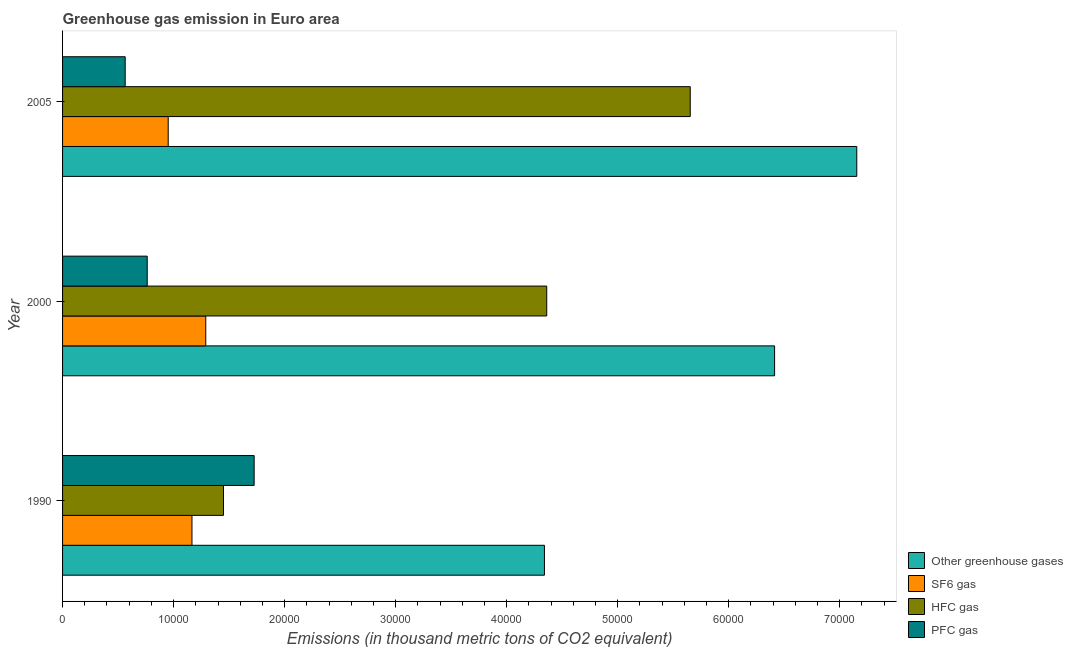Are the number of bars per tick equal to the number of legend labels?
Give a very brief answer. Yes. How many bars are there on the 3rd tick from the top?
Offer a terse response. 4. How many bars are there on the 2nd tick from the bottom?
Ensure brevity in your answer.  4. What is the label of the 3rd group of bars from the top?
Ensure brevity in your answer.  1990. What is the emission of hfc gas in 2000?
Keep it short and to the point. 4.36e+04. Across all years, what is the maximum emission of hfc gas?
Make the answer very short. 5.65e+04. Across all years, what is the minimum emission of pfc gas?
Make the answer very short. 5640.06. In which year was the emission of sf6 gas minimum?
Ensure brevity in your answer.  2005. What is the total emission of sf6 gas in the graph?
Your answer should be compact. 3.41e+04. What is the difference between the emission of greenhouse gases in 2000 and that in 2005?
Keep it short and to the point. -7401.3. What is the difference between the emission of pfc gas in 2000 and the emission of hfc gas in 1990?
Ensure brevity in your answer.  -6866.6. What is the average emission of hfc gas per year?
Give a very brief answer. 3.82e+04. In the year 2000, what is the difference between the emission of pfc gas and emission of sf6 gas?
Offer a terse response. -5272.2. In how many years, is the emission of hfc gas greater than 42000 thousand metric tons?
Offer a terse response. 2. What is the ratio of the emission of sf6 gas in 2000 to that in 2005?
Ensure brevity in your answer.  1.36. Is the difference between the emission of pfc gas in 1990 and 2000 greater than the difference between the emission of sf6 gas in 1990 and 2000?
Offer a terse response. Yes. What is the difference between the highest and the second highest emission of hfc gas?
Keep it short and to the point. 1.29e+04. What is the difference between the highest and the lowest emission of greenhouse gases?
Offer a terse response. 2.81e+04. Is it the case that in every year, the sum of the emission of greenhouse gases and emission of sf6 gas is greater than the sum of emission of hfc gas and emission of pfc gas?
Your answer should be very brief. Yes. What does the 4th bar from the top in 2000 represents?
Your response must be concise. Other greenhouse gases. What does the 1st bar from the bottom in 1990 represents?
Keep it short and to the point. Other greenhouse gases. How many years are there in the graph?
Ensure brevity in your answer.  3. Are the values on the major ticks of X-axis written in scientific E-notation?
Your answer should be very brief. No. Does the graph contain any zero values?
Provide a short and direct response. No. Does the graph contain grids?
Your answer should be very brief. No. Where does the legend appear in the graph?
Provide a succinct answer. Bottom right. How many legend labels are there?
Provide a short and direct response. 4. How are the legend labels stacked?
Give a very brief answer. Vertical. What is the title of the graph?
Keep it short and to the point. Greenhouse gas emission in Euro area. What is the label or title of the X-axis?
Offer a terse response. Emissions (in thousand metric tons of CO2 equivalent). What is the label or title of the Y-axis?
Your response must be concise. Year. What is the Emissions (in thousand metric tons of CO2 equivalent) of Other greenhouse gases in 1990?
Provide a succinct answer. 4.34e+04. What is the Emissions (in thousand metric tons of CO2 equivalent) of SF6 gas in 1990?
Give a very brief answer. 1.17e+04. What is the Emissions (in thousand metric tons of CO2 equivalent) of HFC gas in 1990?
Offer a very short reply. 1.45e+04. What is the Emissions (in thousand metric tons of CO2 equivalent) of PFC gas in 1990?
Your answer should be compact. 1.73e+04. What is the Emissions (in thousand metric tons of CO2 equivalent) in Other greenhouse gases in 2000?
Offer a terse response. 6.41e+04. What is the Emissions (in thousand metric tons of CO2 equivalent) of SF6 gas in 2000?
Your response must be concise. 1.29e+04. What is the Emissions (in thousand metric tons of CO2 equivalent) of HFC gas in 2000?
Make the answer very short. 4.36e+04. What is the Emissions (in thousand metric tons of CO2 equivalent) in PFC gas in 2000?
Provide a succinct answer. 7625. What is the Emissions (in thousand metric tons of CO2 equivalent) of Other greenhouse gases in 2005?
Provide a succinct answer. 7.15e+04. What is the Emissions (in thousand metric tons of CO2 equivalent) of SF6 gas in 2005?
Your response must be concise. 9513.72. What is the Emissions (in thousand metric tons of CO2 equivalent) in HFC gas in 2005?
Ensure brevity in your answer.  5.65e+04. What is the Emissions (in thousand metric tons of CO2 equivalent) in PFC gas in 2005?
Provide a short and direct response. 5640.06. Across all years, what is the maximum Emissions (in thousand metric tons of CO2 equivalent) in Other greenhouse gases?
Offer a very short reply. 7.15e+04. Across all years, what is the maximum Emissions (in thousand metric tons of CO2 equivalent) in SF6 gas?
Offer a terse response. 1.29e+04. Across all years, what is the maximum Emissions (in thousand metric tons of CO2 equivalent) of HFC gas?
Offer a terse response. 5.65e+04. Across all years, what is the maximum Emissions (in thousand metric tons of CO2 equivalent) in PFC gas?
Offer a terse response. 1.73e+04. Across all years, what is the minimum Emissions (in thousand metric tons of CO2 equivalent) in Other greenhouse gases?
Give a very brief answer. 4.34e+04. Across all years, what is the minimum Emissions (in thousand metric tons of CO2 equivalent) in SF6 gas?
Provide a short and direct response. 9513.72. Across all years, what is the minimum Emissions (in thousand metric tons of CO2 equivalent) in HFC gas?
Keep it short and to the point. 1.45e+04. Across all years, what is the minimum Emissions (in thousand metric tons of CO2 equivalent) of PFC gas?
Give a very brief answer. 5640.06. What is the total Emissions (in thousand metric tons of CO2 equivalent) of Other greenhouse gases in the graph?
Give a very brief answer. 1.79e+05. What is the total Emissions (in thousand metric tons of CO2 equivalent) of SF6 gas in the graph?
Keep it short and to the point. 3.41e+04. What is the total Emissions (in thousand metric tons of CO2 equivalent) of HFC gas in the graph?
Provide a short and direct response. 1.15e+05. What is the total Emissions (in thousand metric tons of CO2 equivalent) in PFC gas in the graph?
Your answer should be compact. 3.05e+04. What is the difference between the Emissions (in thousand metric tons of CO2 equivalent) in Other greenhouse gases in 1990 and that in 2000?
Your answer should be compact. -2.07e+04. What is the difference between the Emissions (in thousand metric tons of CO2 equivalent) of SF6 gas in 1990 and that in 2000?
Keep it short and to the point. -1242.6. What is the difference between the Emissions (in thousand metric tons of CO2 equivalent) of HFC gas in 1990 and that in 2000?
Keep it short and to the point. -2.91e+04. What is the difference between the Emissions (in thousand metric tons of CO2 equivalent) of PFC gas in 1990 and that in 2000?
Make the answer very short. 9630.1. What is the difference between the Emissions (in thousand metric tons of CO2 equivalent) in Other greenhouse gases in 1990 and that in 2005?
Offer a terse response. -2.81e+04. What is the difference between the Emissions (in thousand metric tons of CO2 equivalent) in SF6 gas in 1990 and that in 2005?
Provide a short and direct response. 2140.88. What is the difference between the Emissions (in thousand metric tons of CO2 equivalent) in HFC gas in 1990 and that in 2005?
Make the answer very short. -4.20e+04. What is the difference between the Emissions (in thousand metric tons of CO2 equivalent) of PFC gas in 1990 and that in 2005?
Make the answer very short. 1.16e+04. What is the difference between the Emissions (in thousand metric tons of CO2 equivalent) in Other greenhouse gases in 2000 and that in 2005?
Provide a short and direct response. -7401.3. What is the difference between the Emissions (in thousand metric tons of CO2 equivalent) in SF6 gas in 2000 and that in 2005?
Give a very brief answer. 3383.48. What is the difference between the Emissions (in thousand metric tons of CO2 equivalent) of HFC gas in 2000 and that in 2005?
Offer a very short reply. -1.29e+04. What is the difference between the Emissions (in thousand metric tons of CO2 equivalent) in PFC gas in 2000 and that in 2005?
Provide a succinct answer. 1984.94. What is the difference between the Emissions (in thousand metric tons of CO2 equivalent) in Other greenhouse gases in 1990 and the Emissions (in thousand metric tons of CO2 equivalent) in SF6 gas in 2000?
Provide a short and direct response. 3.05e+04. What is the difference between the Emissions (in thousand metric tons of CO2 equivalent) of Other greenhouse gases in 1990 and the Emissions (in thousand metric tons of CO2 equivalent) of HFC gas in 2000?
Ensure brevity in your answer.  -206.3. What is the difference between the Emissions (in thousand metric tons of CO2 equivalent) of Other greenhouse gases in 1990 and the Emissions (in thousand metric tons of CO2 equivalent) of PFC gas in 2000?
Ensure brevity in your answer.  3.58e+04. What is the difference between the Emissions (in thousand metric tons of CO2 equivalent) in SF6 gas in 1990 and the Emissions (in thousand metric tons of CO2 equivalent) in HFC gas in 2000?
Ensure brevity in your answer.  -3.20e+04. What is the difference between the Emissions (in thousand metric tons of CO2 equivalent) in SF6 gas in 1990 and the Emissions (in thousand metric tons of CO2 equivalent) in PFC gas in 2000?
Provide a succinct answer. 4029.6. What is the difference between the Emissions (in thousand metric tons of CO2 equivalent) of HFC gas in 1990 and the Emissions (in thousand metric tons of CO2 equivalent) of PFC gas in 2000?
Your answer should be very brief. 6866.6. What is the difference between the Emissions (in thousand metric tons of CO2 equivalent) of Other greenhouse gases in 1990 and the Emissions (in thousand metric tons of CO2 equivalent) of SF6 gas in 2005?
Offer a very short reply. 3.39e+04. What is the difference between the Emissions (in thousand metric tons of CO2 equivalent) of Other greenhouse gases in 1990 and the Emissions (in thousand metric tons of CO2 equivalent) of HFC gas in 2005?
Provide a short and direct response. -1.31e+04. What is the difference between the Emissions (in thousand metric tons of CO2 equivalent) of Other greenhouse gases in 1990 and the Emissions (in thousand metric tons of CO2 equivalent) of PFC gas in 2005?
Your response must be concise. 3.78e+04. What is the difference between the Emissions (in thousand metric tons of CO2 equivalent) in SF6 gas in 1990 and the Emissions (in thousand metric tons of CO2 equivalent) in HFC gas in 2005?
Keep it short and to the point. -4.49e+04. What is the difference between the Emissions (in thousand metric tons of CO2 equivalent) of SF6 gas in 1990 and the Emissions (in thousand metric tons of CO2 equivalent) of PFC gas in 2005?
Offer a very short reply. 6014.54. What is the difference between the Emissions (in thousand metric tons of CO2 equivalent) in HFC gas in 1990 and the Emissions (in thousand metric tons of CO2 equivalent) in PFC gas in 2005?
Offer a very short reply. 8851.54. What is the difference between the Emissions (in thousand metric tons of CO2 equivalent) of Other greenhouse gases in 2000 and the Emissions (in thousand metric tons of CO2 equivalent) of SF6 gas in 2005?
Give a very brief answer. 5.46e+04. What is the difference between the Emissions (in thousand metric tons of CO2 equivalent) in Other greenhouse gases in 2000 and the Emissions (in thousand metric tons of CO2 equivalent) in HFC gas in 2005?
Offer a terse response. 7598.1. What is the difference between the Emissions (in thousand metric tons of CO2 equivalent) in Other greenhouse gases in 2000 and the Emissions (in thousand metric tons of CO2 equivalent) in PFC gas in 2005?
Ensure brevity in your answer.  5.85e+04. What is the difference between the Emissions (in thousand metric tons of CO2 equivalent) of SF6 gas in 2000 and the Emissions (in thousand metric tons of CO2 equivalent) of HFC gas in 2005?
Provide a short and direct response. -4.36e+04. What is the difference between the Emissions (in thousand metric tons of CO2 equivalent) of SF6 gas in 2000 and the Emissions (in thousand metric tons of CO2 equivalent) of PFC gas in 2005?
Provide a short and direct response. 7257.14. What is the difference between the Emissions (in thousand metric tons of CO2 equivalent) of HFC gas in 2000 and the Emissions (in thousand metric tons of CO2 equivalent) of PFC gas in 2005?
Make the answer very short. 3.80e+04. What is the average Emissions (in thousand metric tons of CO2 equivalent) in Other greenhouse gases per year?
Keep it short and to the point. 5.97e+04. What is the average Emissions (in thousand metric tons of CO2 equivalent) in SF6 gas per year?
Your answer should be compact. 1.14e+04. What is the average Emissions (in thousand metric tons of CO2 equivalent) in HFC gas per year?
Provide a short and direct response. 3.82e+04. What is the average Emissions (in thousand metric tons of CO2 equivalent) in PFC gas per year?
Offer a very short reply. 1.02e+04. In the year 1990, what is the difference between the Emissions (in thousand metric tons of CO2 equivalent) of Other greenhouse gases and Emissions (in thousand metric tons of CO2 equivalent) of SF6 gas?
Your answer should be compact. 3.17e+04. In the year 1990, what is the difference between the Emissions (in thousand metric tons of CO2 equivalent) of Other greenhouse gases and Emissions (in thousand metric tons of CO2 equivalent) of HFC gas?
Give a very brief answer. 2.89e+04. In the year 1990, what is the difference between the Emissions (in thousand metric tons of CO2 equivalent) in Other greenhouse gases and Emissions (in thousand metric tons of CO2 equivalent) in PFC gas?
Provide a short and direct response. 2.61e+04. In the year 1990, what is the difference between the Emissions (in thousand metric tons of CO2 equivalent) in SF6 gas and Emissions (in thousand metric tons of CO2 equivalent) in HFC gas?
Your answer should be very brief. -2837. In the year 1990, what is the difference between the Emissions (in thousand metric tons of CO2 equivalent) in SF6 gas and Emissions (in thousand metric tons of CO2 equivalent) in PFC gas?
Your answer should be very brief. -5600.5. In the year 1990, what is the difference between the Emissions (in thousand metric tons of CO2 equivalent) in HFC gas and Emissions (in thousand metric tons of CO2 equivalent) in PFC gas?
Your answer should be compact. -2763.5. In the year 2000, what is the difference between the Emissions (in thousand metric tons of CO2 equivalent) of Other greenhouse gases and Emissions (in thousand metric tons of CO2 equivalent) of SF6 gas?
Provide a succinct answer. 5.12e+04. In the year 2000, what is the difference between the Emissions (in thousand metric tons of CO2 equivalent) of Other greenhouse gases and Emissions (in thousand metric tons of CO2 equivalent) of HFC gas?
Offer a terse response. 2.05e+04. In the year 2000, what is the difference between the Emissions (in thousand metric tons of CO2 equivalent) in Other greenhouse gases and Emissions (in thousand metric tons of CO2 equivalent) in PFC gas?
Your response must be concise. 5.65e+04. In the year 2000, what is the difference between the Emissions (in thousand metric tons of CO2 equivalent) in SF6 gas and Emissions (in thousand metric tons of CO2 equivalent) in HFC gas?
Offer a terse response. -3.07e+04. In the year 2000, what is the difference between the Emissions (in thousand metric tons of CO2 equivalent) in SF6 gas and Emissions (in thousand metric tons of CO2 equivalent) in PFC gas?
Keep it short and to the point. 5272.2. In the year 2000, what is the difference between the Emissions (in thousand metric tons of CO2 equivalent) of HFC gas and Emissions (in thousand metric tons of CO2 equivalent) of PFC gas?
Ensure brevity in your answer.  3.60e+04. In the year 2005, what is the difference between the Emissions (in thousand metric tons of CO2 equivalent) in Other greenhouse gases and Emissions (in thousand metric tons of CO2 equivalent) in SF6 gas?
Provide a succinct answer. 6.20e+04. In the year 2005, what is the difference between the Emissions (in thousand metric tons of CO2 equivalent) of Other greenhouse gases and Emissions (in thousand metric tons of CO2 equivalent) of HFC gas?
Your answer should be very brief. 1.50e+04. In the year 2005, what is the difference between the Emissions (in thousand metric tons of CO2 equivalent) of Other greenhouse gases and Emissions (in thousand metric tons of CO2 equivalent) of PFC gas?
Keep it short and to the point. 6.59e+04. In the year 2005, what is the difference between the Emissions (in thousand metric tons of CO2 equivalent) in SF6 gas and Emissions (in thousand metric tons of CO2 equivalent) in HFC gas?
Give a very brief answer. -4.70e+04. In the year 2005, what is the difference between the Emissions (in thousand metric tons of CO2 equivalent) of SF6 gas and Emissions (in thousand metric tons of CO2 equivalent) of PFC gas?
Your answer should be compact. 3873.66. In the year 2005, what is the difference between the Emissions (in thousand metric tons of CO2 equivalent) in HFC gas and Emissions (in thousand metric tons of CO2 equivalent) in PFC gas?
Offer a terse response. 5.09e+04. What is the ratio of the Emissions (in thousand metric tons of CO2 equivalent) of Other greenhouse gases in 1990 to that in 2000?
Your answer should be compact. 0.68. What is the ratio of the Emissions (in thousand metric tons of CO2 equivalent) of SF6 gas in 1990 to that in 2000?
Make the answer very short. 0.9. What is the ratio of the Emissions (in thousand metric tons of CO2 equivalent) in HFC gas in 1990 to that in 2000?
Provide a succinct answer. 0.33. What is the ratio of the Emissions (in thousand metric tons of CO2 equivalent) of PFC gas in 1990 to that in 2000?
Your answer should be very brief. 2.26. What is the ratio of the Emissions (in thousand metric tons of CO2 equivalent) in Other greenhouse gases in 1990 to that in 2005?
Provide a succinct answer. 0.61. What is the ratio of the Emissions (in thousand metric tons of CO2 equivalent) of SF6 gas in 1990 to that in 2005?
Your answer should be very brief. 1.23. What is the ratio of the Emissions (in thousand metric tons of CO2 equivalent) of HFC gas in 1990 to that in 2005?
Provide a succinct answer. 0.26. What is the ratio of the Emissions (in thousand metric tons of CO2 equivalent) of PFC gas in 1990 to that in 2005?
Offer a very short reply. 3.06. What is the ratio of the Emissions (in thousand metric tons of CO2 equivalent) in Other greenhouse gases in 2000 to that in 2005?
Ensure brevity in your answer.  0.9. What is the ratio of the Emissions (in thousand metric tons of CO2 equivalent) in SF6 gas in 2000 to that in 2005?
Ensure brevity in your answer.  1.36. What is the ratio of the Emissions (in thousand metric tons of CO2 equivalent) in HFC gas in 2000 to that in 2005?
Make the answer very short. 0.77. What is the ratio of the Emissions (in thousand metric tons of CO2 equivalent) in PFC gas in 2000 to that in 2005?
Keep it short and to the point. 1.35. What is the difference between the highest and the second highest Emissions (in thousand metric tons of CO2 equivalent) of Other greenhouse gases?
Make the answer very short. 7401.3. What is the difference between the highest and the second highest Emissions (in thousand metric tons of CO2 equivalent) in SF6 gas?
Provide a short and direct response. 1242.6. What is the difference between the highest and the second highest Emissions (in thousand metric tons of CO2 equivalent) in HFC gas?
Make the answer very short. 1.29e+04. What is the difference between the highest and the second highest Emissions (in thousand metric tons of CO2 equivalent) of PFC gas?
Your answer should be very brief. 9630.1. What is the difference between the highest and the lowest Emissions (in thousand metric tons of CO2 equivalent) in Other greenhouse gases?
Make the answer very short. 2.81e+04. What is the difference between the highest and the lowest Emissions (in thousand metric tons of CO2 equivalent) in SF6 gas?
Ensure brevity in your answer.  3383.48. What is the difference between the highest and the lowest Emissions (in thousand metric tons of CO2 equivalent) of HFC gas?
Your answer should be very brief. 4.20e+04. What is the difference between the highest and the lowest Emissions (in thousand metric tons of CO2 equivalent) in PFC gas?
Offer a terse response. 1.16e+04. 